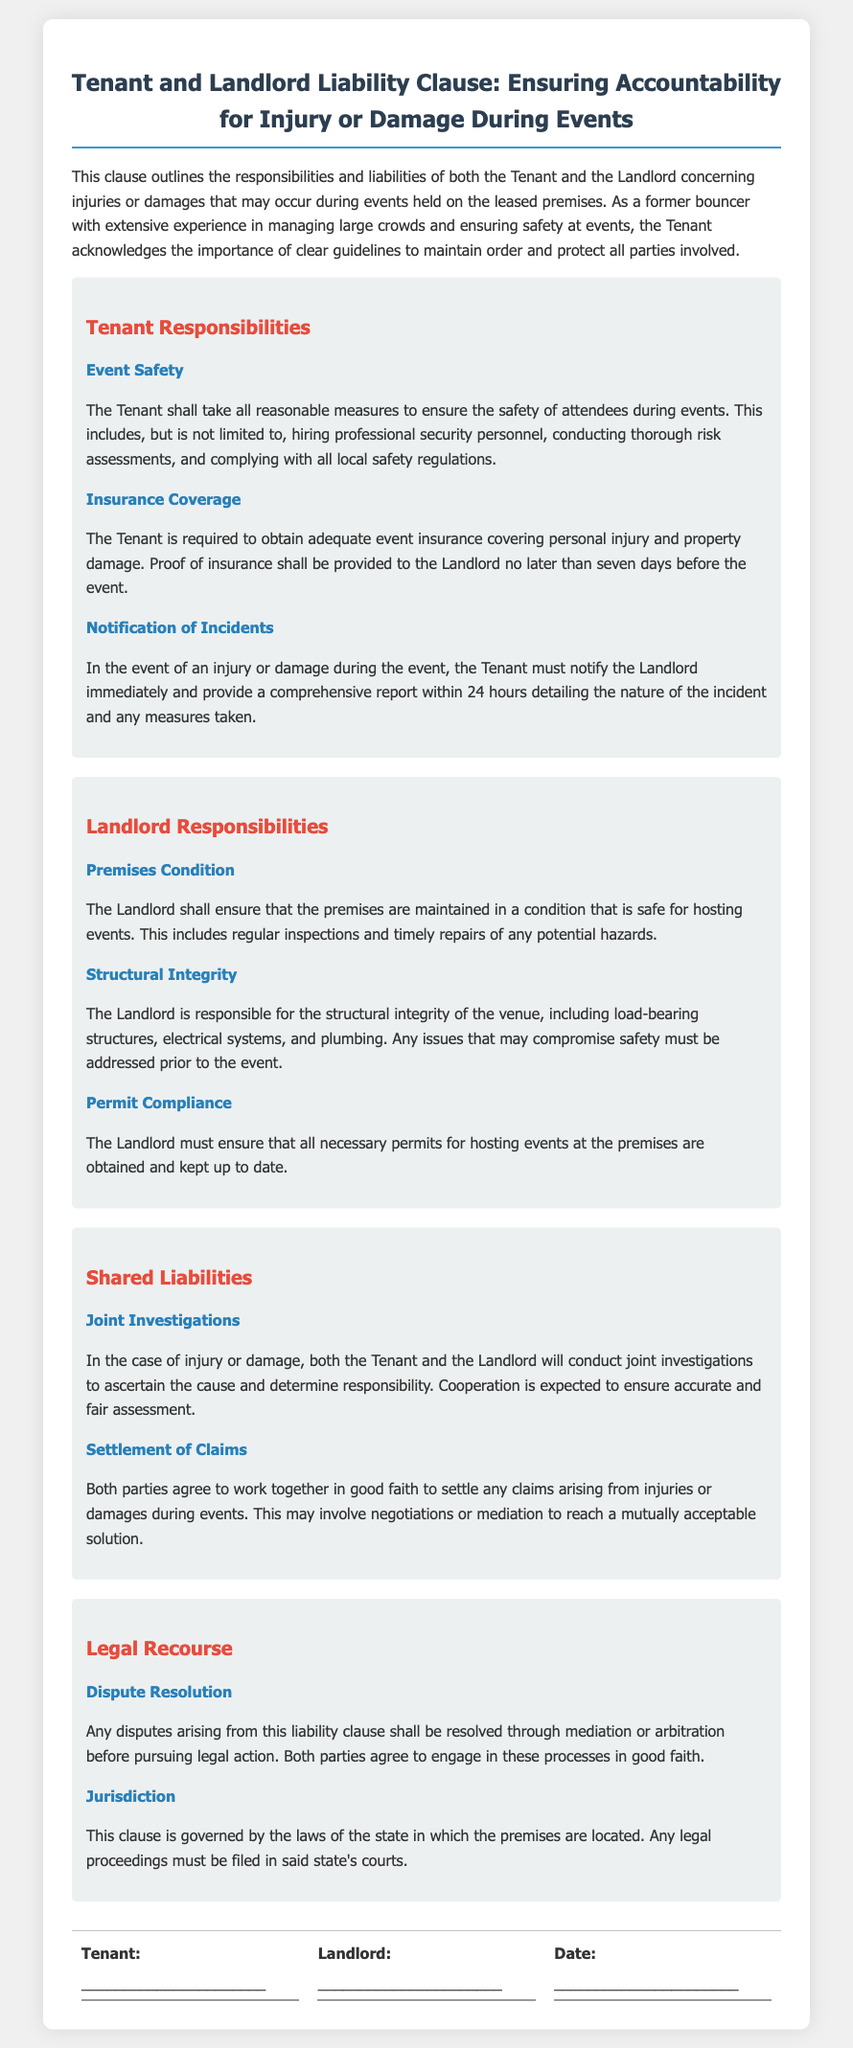What is the title of the document? The title of the document provides a brief description of its content regarding liability and accountability for injury or damage.
Answer: Tenant and Landlord Liability Clause: Ensuring Accountability for Injury or Damage During Events How many days before the event must the Tenant provide proof of insurance? The clause specifies a timeline for the Tenant to deliver documentation of insurance, emphasizing the responsibility of the Tenant.
Answer: Seven days What must the Tenant do in case of an injury or damage? The clause states the actions the Tenant is required to take if an incident occurs during an event, underscoring prompt communication and reporting obligations.
Answer: Notify the Landlord immediately and provide a comprehensive report within 24 hours What is the Landlord responsible for maintaining? The document outlines specific responsibilities of the Landlord to ensure safety and readiness of the venue for events, particularly in maintaining certain conditions.
Answer: Premises condition Which parties agree to settle claims in good faith? The clause emphasizes collaboration between both parties in handling claims, reflecting the spirit of cooperation highlighted in the agreement.
Answer: Both parties What kind of investigations will be conducted in case of an incident? The document specifies the nature of investigations to be performed when an incident occurs, indicating joint responsibility and accountability.
Answer: Joint investigations What is the preferred method for resolving disputes as outlined in the clause? The clause highlights the approach parties must take to settle potential disputes, emphasizing the importance of conflict resolution mechanisms.
Answer: Mediation or arbitration What must the Landlord ensure regarding necessary permits? The responsibility of the Landlord concerning legal compliance for the events is described in the document, particularly about permits.
Answer: Obtained and kept up to date What type of insurance is the Tenant required to obtain? The document specifies the type of insurance coverage required to safeguard against incidents occurring during events.
Answer: Adequate event insurance covering personal injury and property damage 